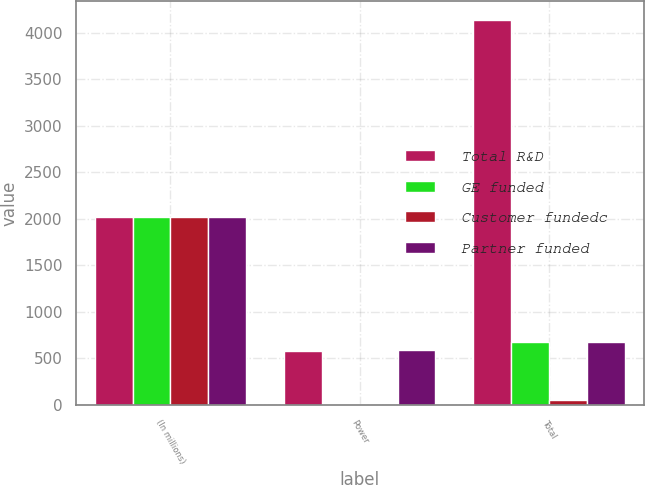Convert chart. <chart><loc_0><loc_0><loc_500><loc_500><stacked_bar_chart><ecel><fcel>(In millions)<fcel>Power<fcel>Total<nl><fcel>Total R&D<fcel>2018<fcel>579<fcel>4134<nl><fcel>GE funded<fcel>2018<fcel>5<fcel>671<nl><fcel>Customer fundedc<fcel>2018<fcel>2<fcel>57<nl><fcel>Partner funded<fcel>2018<fcel>586<fcel>671<nl></chart> 